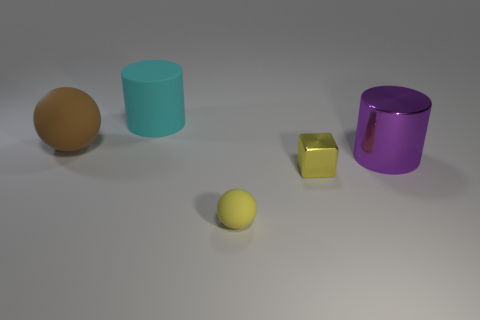Add 1 small red shiny cylinders. How many objects exist? 6 Subtract all cubes. How many objects are left? 4 Subtract all large metallic things. Subtract all big purple metal cylinders. How many objects are left? 3 Add 3 metallic cubes. How many metallic cubes are left? 4 Add 5 big purple shiny cylinders. How many big purple shiny cylinders exist? 6 Subtract 0 gray cylinders. How many objects are left? 5 